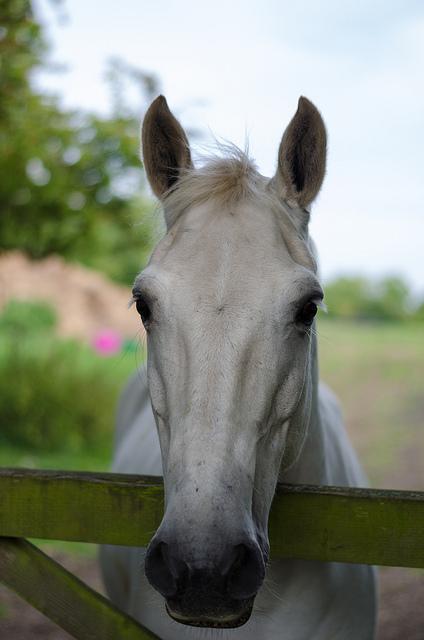What type of animal is this?
Write a very short answer. Horse. Is the horse's face relatively symmetrical?
Short answer required. Yes. What color is the fence beneath the horses head?
Concise answer only. Green. 